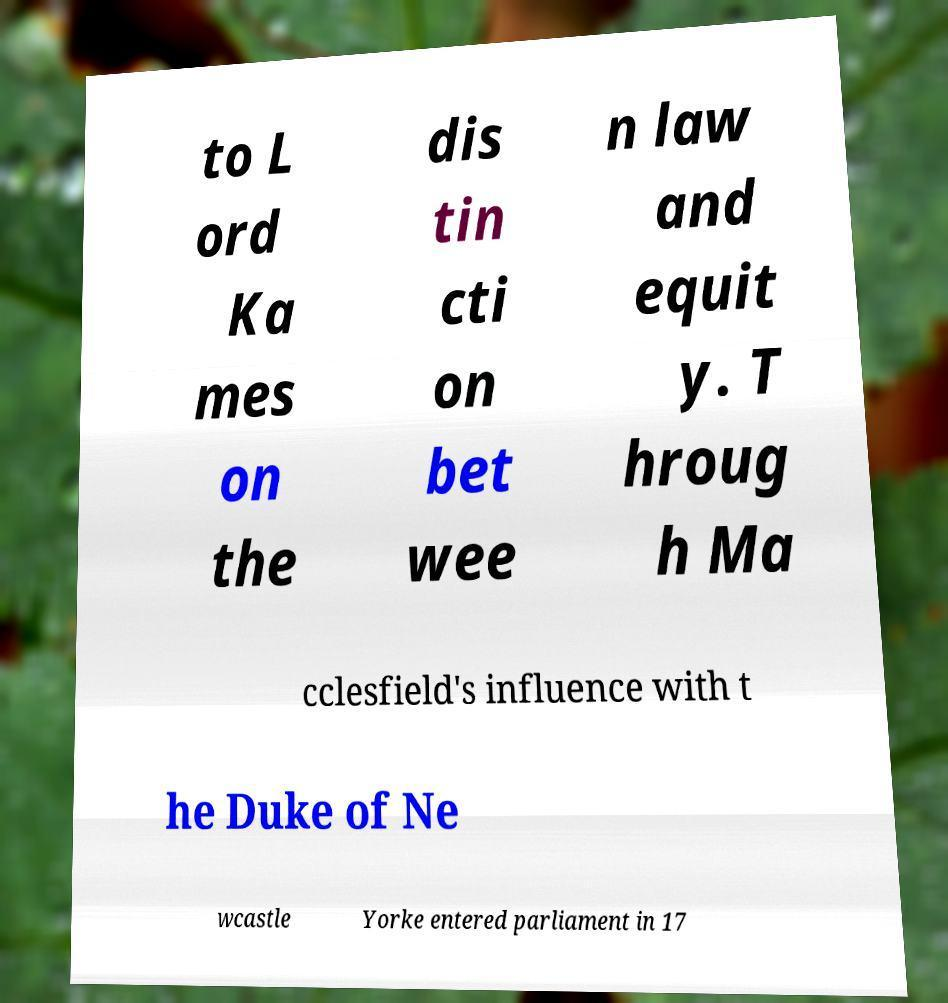I need the written content from this picture converted into text. Can you do that? to L ord Ka mes on the dis tin cti on bet wee n law and equit y. T hroug h Ma cclesfield's influence with t he Duke of Ne wcastle Yorke entered parliament in 17 